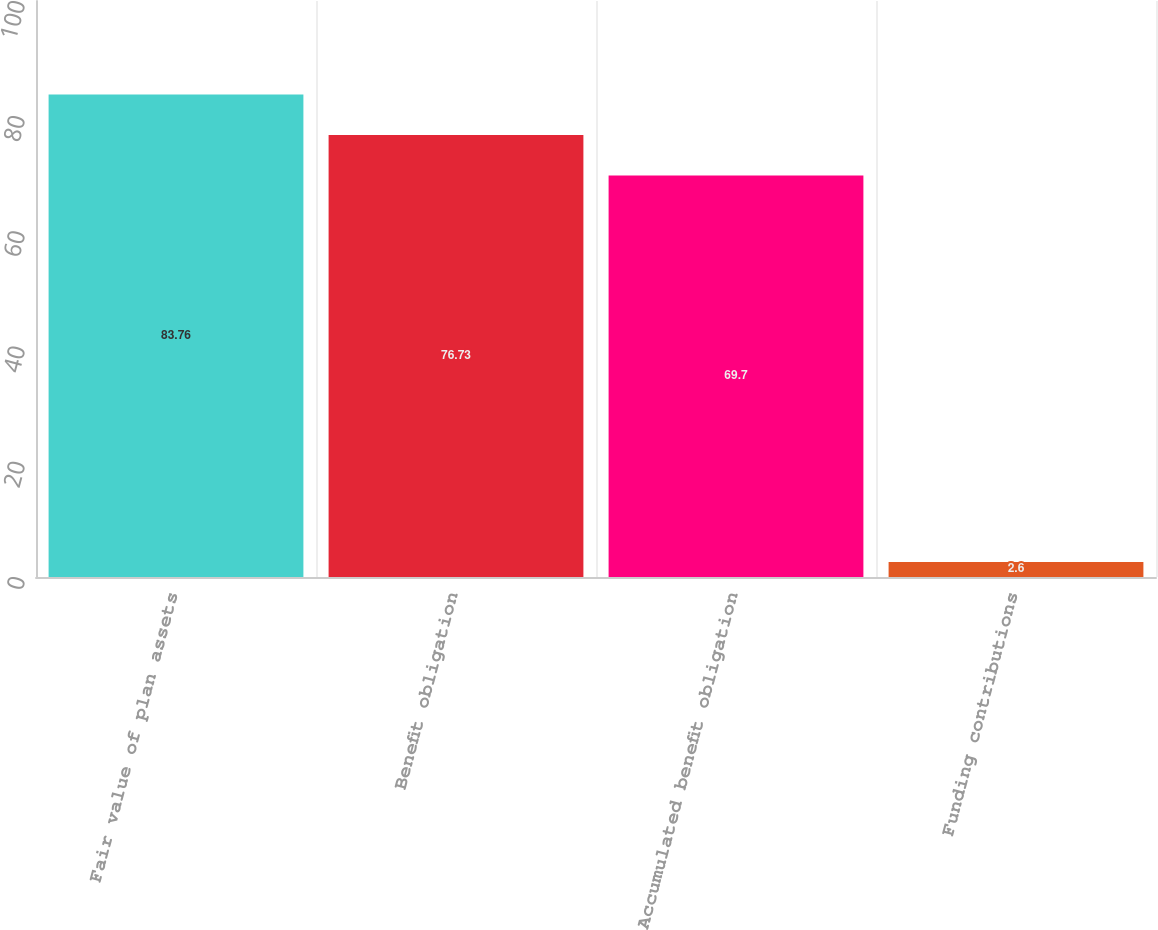Convert chart to OTSL. <chart><loc_0><loc_0><loc_500><loc_500><bar_chart><fcel>Fair value of plan assets<fcel>Benefit obligation<fcel>Accumulated benefit obligation<fcel>Funding contributions<nl><fcel>83.76<fcel>76.73<fcel>69.7<fcel>2.6<nl></chart> 